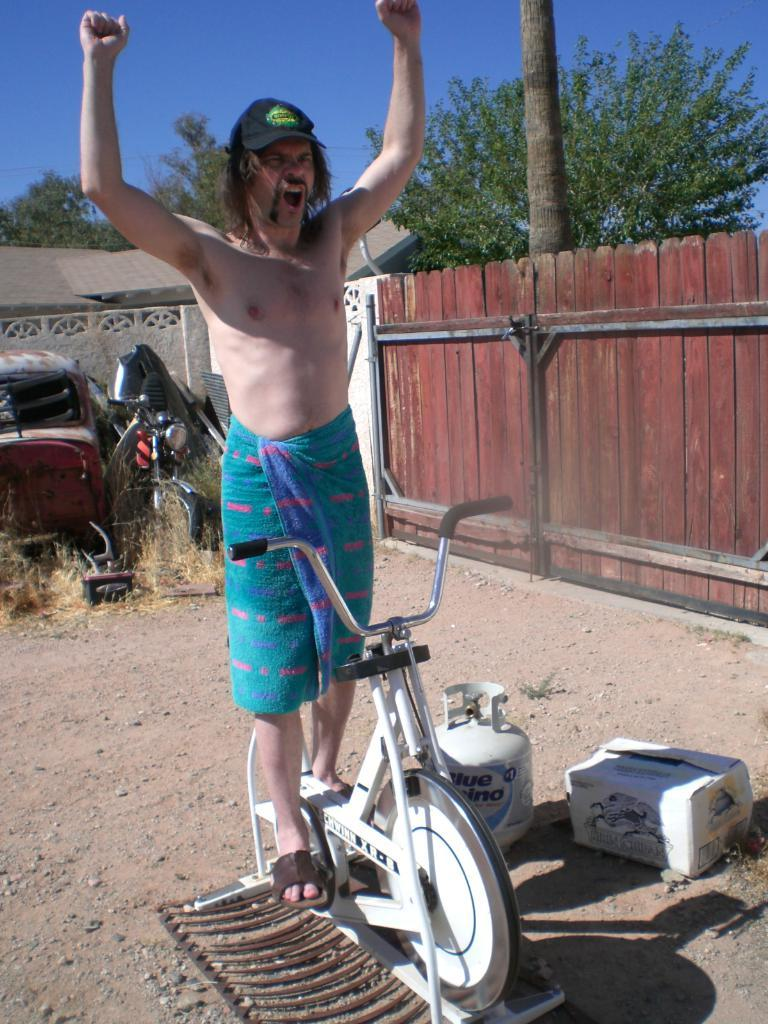What is the person in the image doing? The person is standing on a bicycle. What can be seen in the background of the image? There is a cooker, a box, a wooden fence, a tree, a car, a motorbike, a house, and the sky visible in the background. What type of school can be seen in the image? There is no school present in the image. Can you describe the monkey sitting on the tree in the background? There is no monkey present in the image; only a tree is visible in the background. 